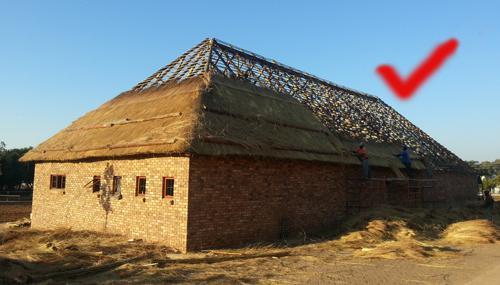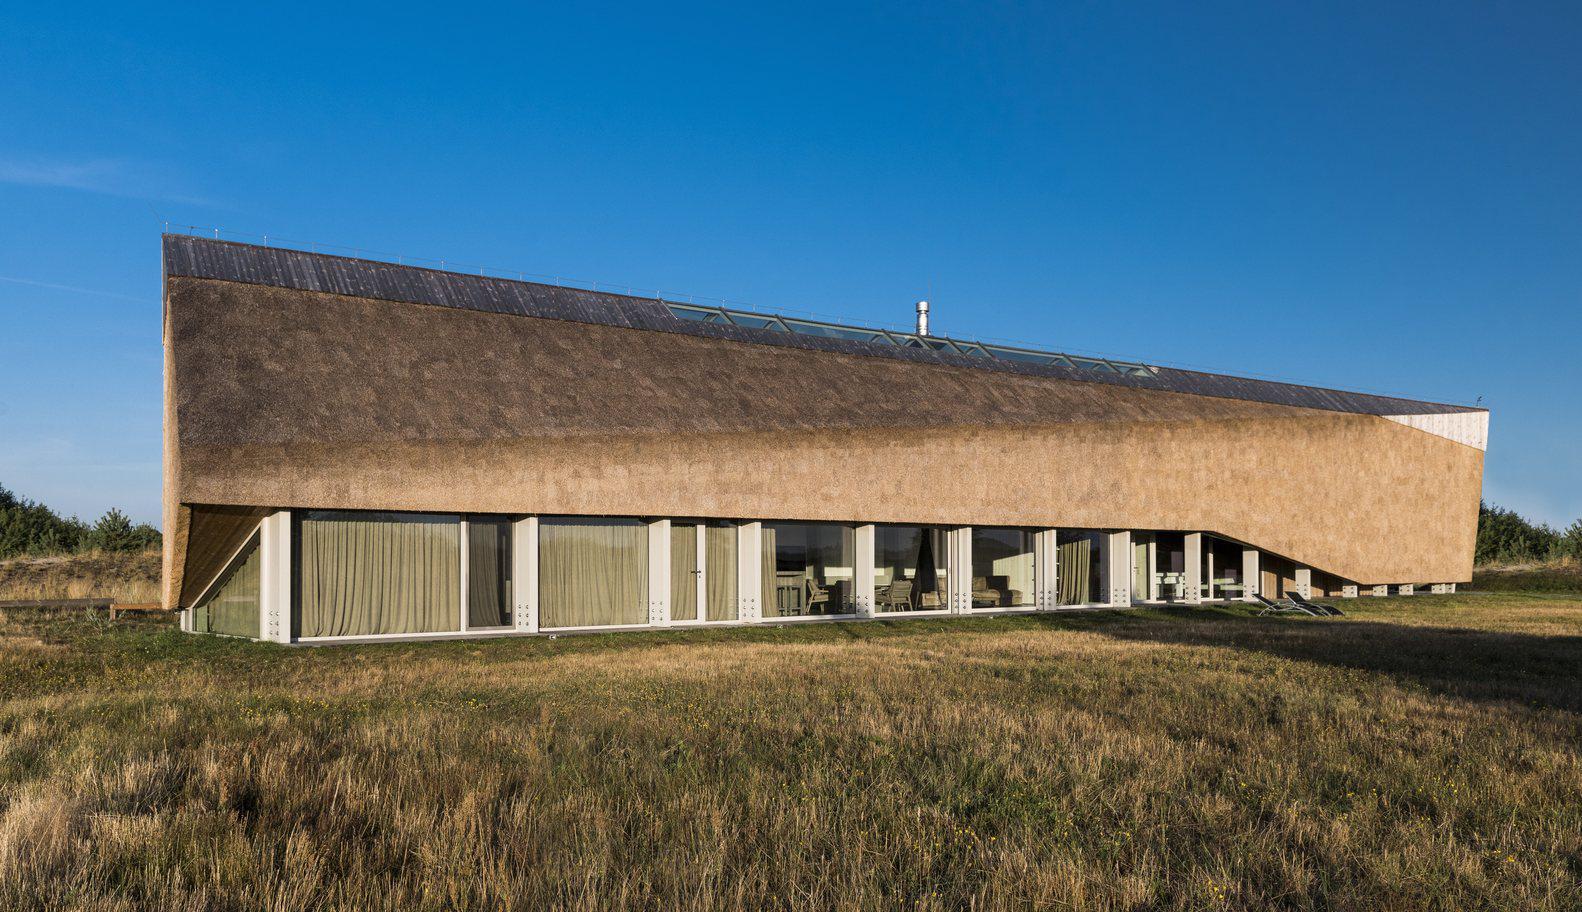The first image is the image on the left, the second image is the image on the right. Evaluate the accuracy of this statement regarding the images: "In the left image, the roof is currently being thatched; the thatching has started, but has not completed.". Is it true? Answer yes or no. Yes. 